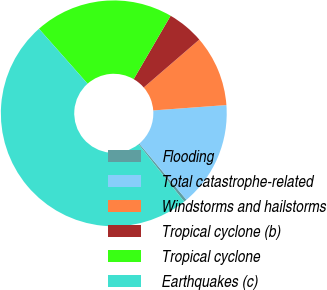<chart> <loc_0><loc_0><loc_500><loc_500><pie_chart><fcel>Flooding<fcel>Total catastrophe-related<fcel>Windstorms and hailstorms<fcel>Tropical cyclone (b)<fcel>Tropical cyclone<fcel>Earthquakes (c)<nl><fcel>0.41%<fcel>15.04%<fcel>10.16%<fcel>5.28%<fcel>19.92%<fcel>49.19%<nl></chart> 